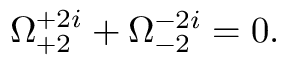Convert formula to latex. <formula><loc_0><loc_0><loc_500><loc_500>\Omega _ { + 2 } ^ { + 2 i } + \Omega _ { - 2 } ^ { - 2 i } = 0 .</formula> 